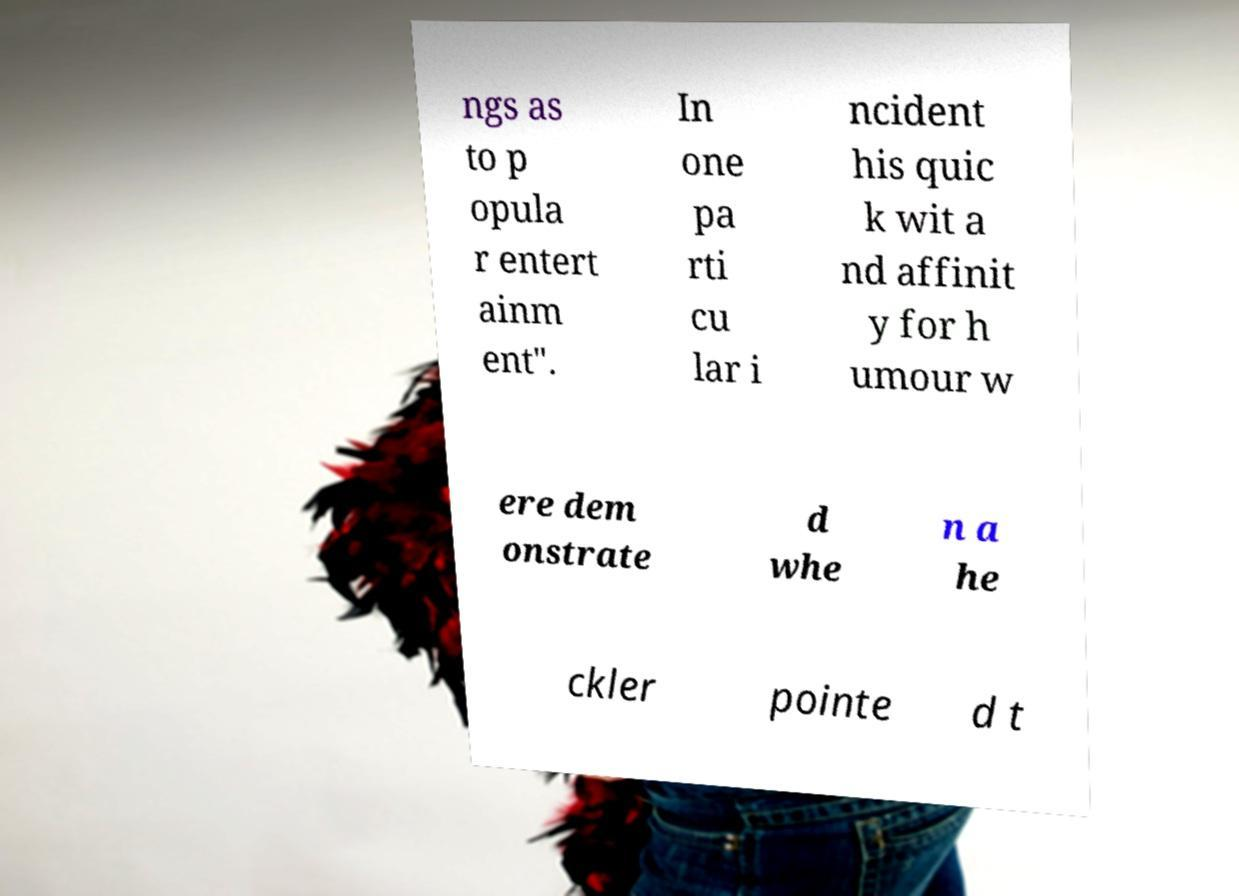Please identify and transcribe the text found in this image. ngs as to p opula r entert ainm ent". In one pa rti cu lar i ncident his quic k wit a nd affinit y for h umour w ere dem onstrate d whe n a he ckler pointe d t 